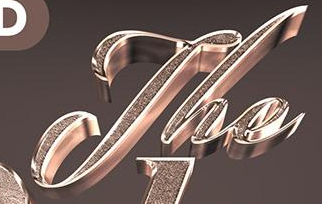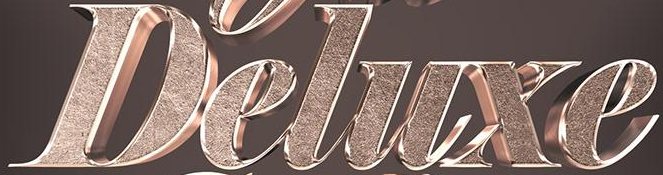Read the text content from these images in order, separated by a semicolon. The; Deluxe 